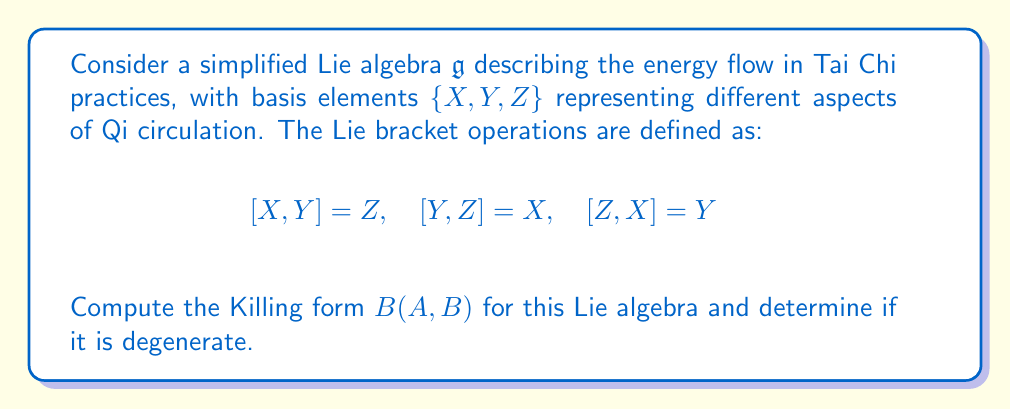Show me your answer to this math problem. To compute the Killing form for the given Lie algebra, we follow these steps:

1) The Killing form is defined as $B(A,B) = \text{tr}(\text{ad}_A \circ \text{ad}_B)$, where $\text{ad}_A$ is the adjoint representation of $A$.

2) First, we need to find the matrix representations of $\text{ad}_X$, $\text{ad}_Y$, and $\text{ad}_Z$:

   For $\text{ad}_X$: 
   $$\text{ad}_X(X) = 0, \quad \text{ad}_X(Y) = Z, \quad \text{ad}_X(Z) = -Y$$
   So, $\text{ad}_X = \begin{pmatrix} 0 & 0 & 0 \\ 0 & 0 & -1 \\ 0 & 1 & 0 \end{pmatrix}$

   Similarly,
   $\text{ad}_Y = \begin{pmatrix} 0 & 0 & 1 \\ 0 & 0 & 0 \\ -1 & 0 & 0 \end{pmatrix}$
   
   $\text{ad}_Z = \begin{pmatrix} 0 & -1 & 0 \\ 1 & 0 & 0 \\ 0 & 0 & 0 \end{pmatrix}$

3) Now, we compute $B(A,B)$ for all pairs of basis elements:

   $B(X,X) = \text{tr}(\text{ad}_X \circ \text{ad}_X) = \text{tr}(\begin{pmatrix} 0 & 0 & 0 \\ 0 & -1 & 0 \\ 0 & 0 & -1 \end{pmatrix}) = -2$

   $B(Y,Y) = \text{tr}(\text{ad}_Y \circ \text{ad}_Y) = -2$

   $B(Z,Z) = \text{tr}(\text{ad}_Z \circ \text{ad}_Z) = -2$

   $B(X,Y) = B(Y,X) = \text{tr}(\text{ad}_X \circ \text{ad}_Y) = 0$

   $B(X,Z) = B(Z,X) = \text{tr}(\text{ad}_X \circ \text{ad}_Z) = 0$

   $B(Y,Z) = B(Z,Y) = \text{tr}(\text{ad}_Y \circ \text{ad}_Z) = 0$

4) The Killing form matrix is therefore:

   $$B = \begin{pmatrix} -2 & 0 & 0 \\ 0 & -2 & 0 \\ 0 & 0 & -2 \end{pmatrix}$$

5) To determine if the Killing form is degenerate, we check its determinant:

   $\det(B) = (-2)^3 = -8 \neq 0$

   Since the determinant is non-zero, the Killing form is non-degenerate.
Answer: The Killing form for the given Lie algebra is $B = \begin{pmatrix} -2 & 0 & 0 \\ 0 & -2 & 0 \\ 0 & 0 & -2 \end{pmatrix}$. It is non-degenerate as $\det(B) = -8 \neq 0$. 